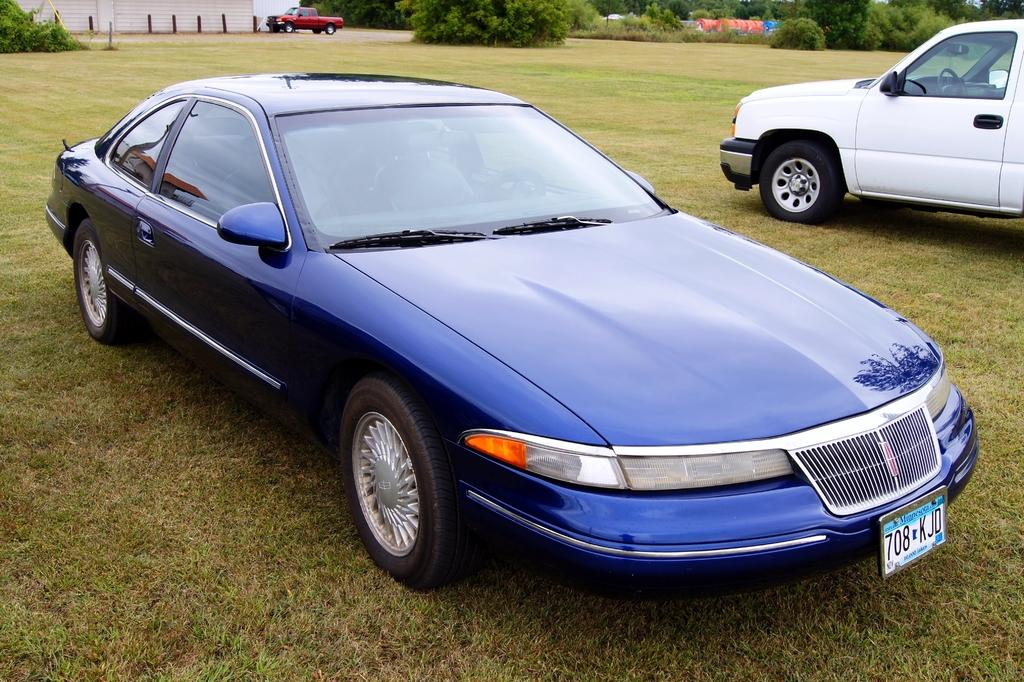What can be seen on the ground in the image? There are vehicles on the ground in the image. What is visible in the background of the image? There is a wall, poles, trees, and some unspecified objects in the background of the image. Can you tell me how many ears are visible on the vehicles in the image? There are no ears present on the vehicles in the image. Is there a shelf in the background of the image? There is no shelf present in the image. 